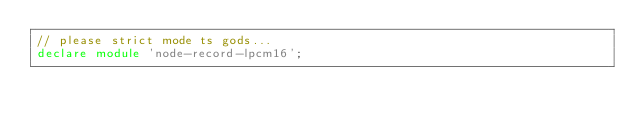Convert code to text. <code><loc_0><loc_0><loc_500><loc_500><_TypeScript_>// please strict mode ts gods...
declare module 'node-record-lpcm16';</code> 